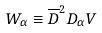Convert formula to latex. <formula><loc_0><loc_0><loc_500><loc_500>W _ { \alpha } \equiv \overline { D } ^ { 2 } D _ { \alpha } V</formula> 